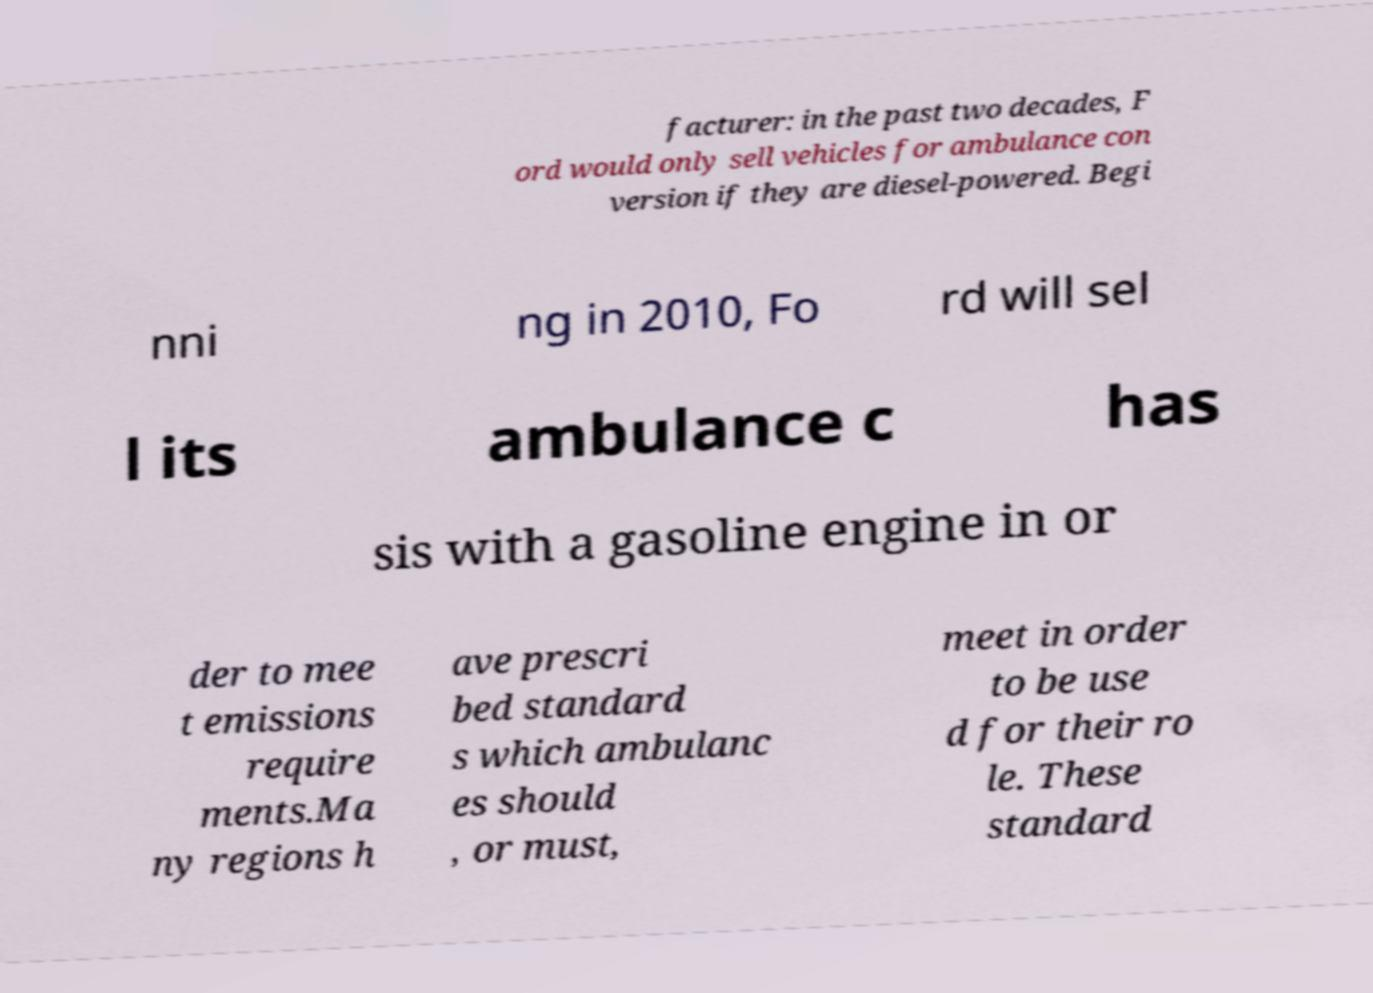Could you extract and type out the text from this image? facturer: in the past two decades, F ord would only sell vehicles for ambulance con version if they are diesel-powered. Begi nni ng in 2010, Fo rd will sel l its ambulance c has sis with a gasoline engine in or der to mee t emissions require ments.Ma ny regions h ave prescri bed standard s which ambulanc es should , or must, meet in order to be use d for their ro le. These standard 